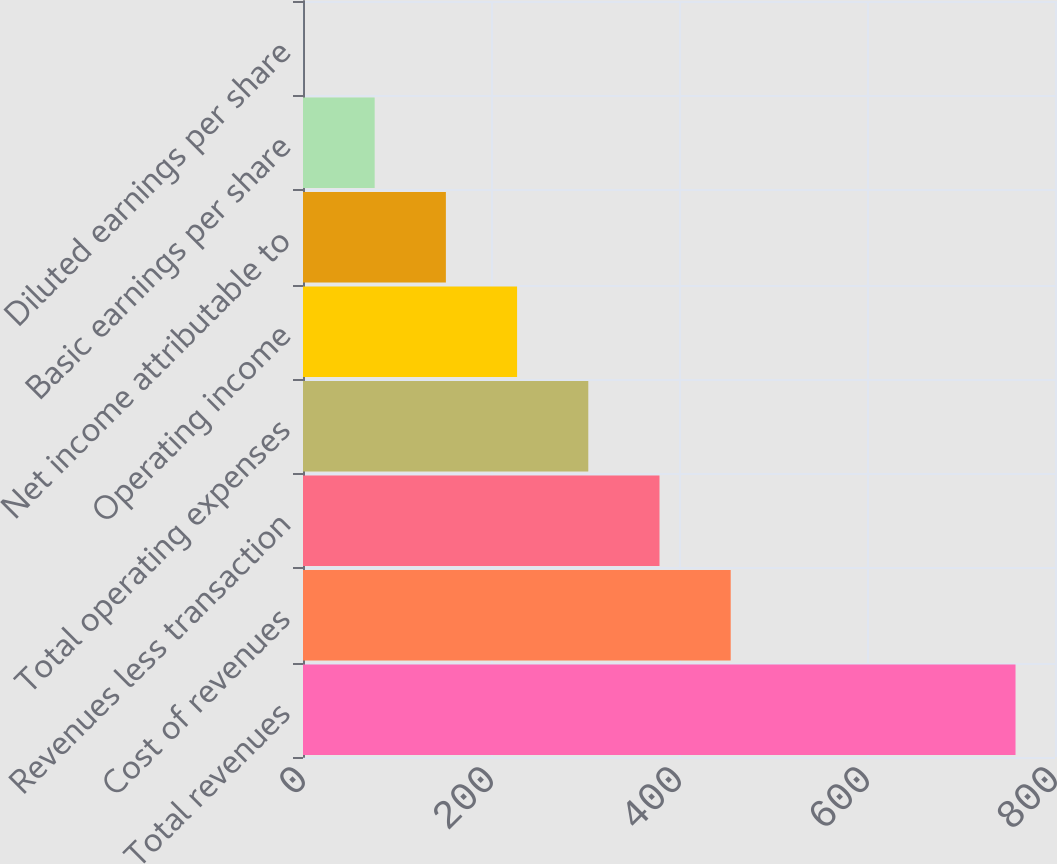Convert chart to OTSL. <chart><loc_0><loc_0><loc_500><loc_500><bar_chart><fcel>Total revenues<fcel>Cost of revenues<fcel>Revenues less transaction<fcel>Total operating expenses<fcel>Operating income<fcel>Net income attributable to<fcel>Basic earnings per share<fcel>Diluted earnings per share<nl><fcel>758<fcel>455<fcel>379.25<fcel>303.5<fcel>227.75<fcel>152<fcel>76.25<fcel>0.5<nl></chart> 